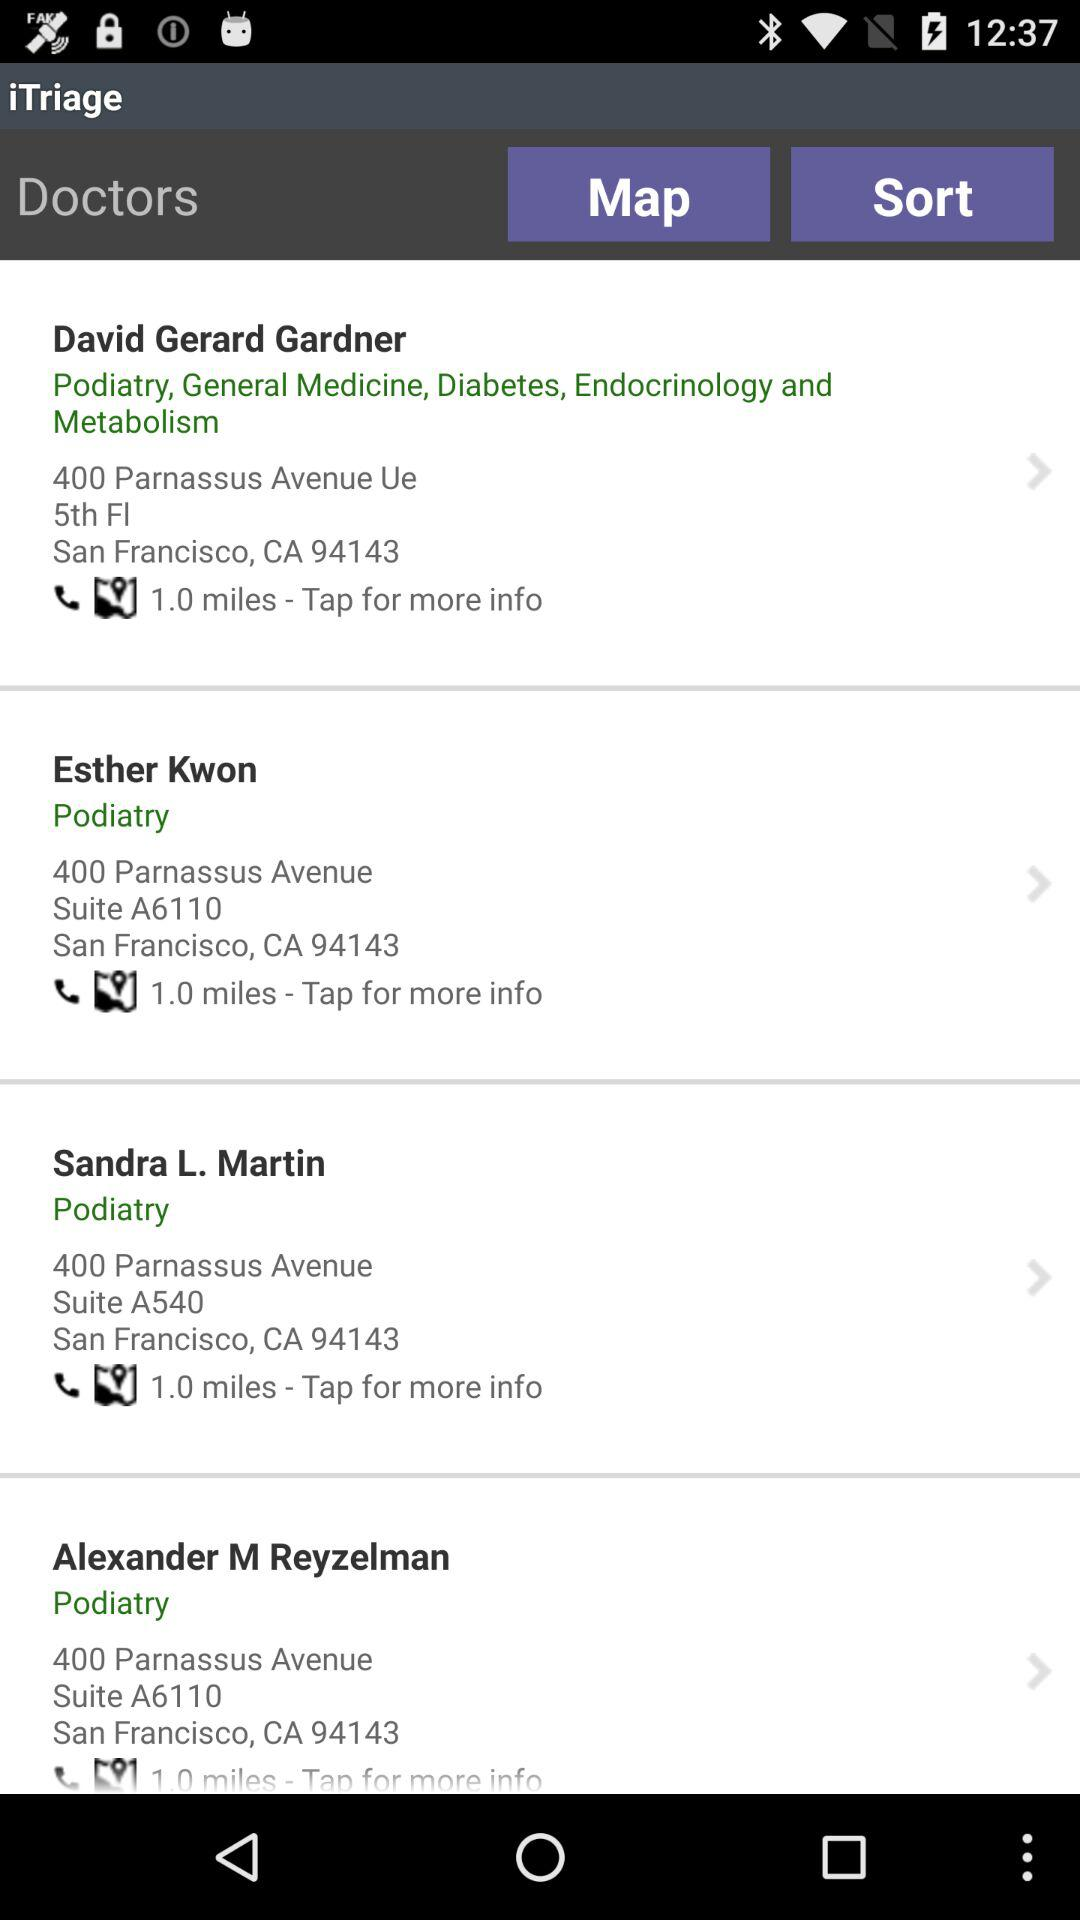What is the map view?
When the provided information is insufficient, respond with <no answer>. <no answer> 